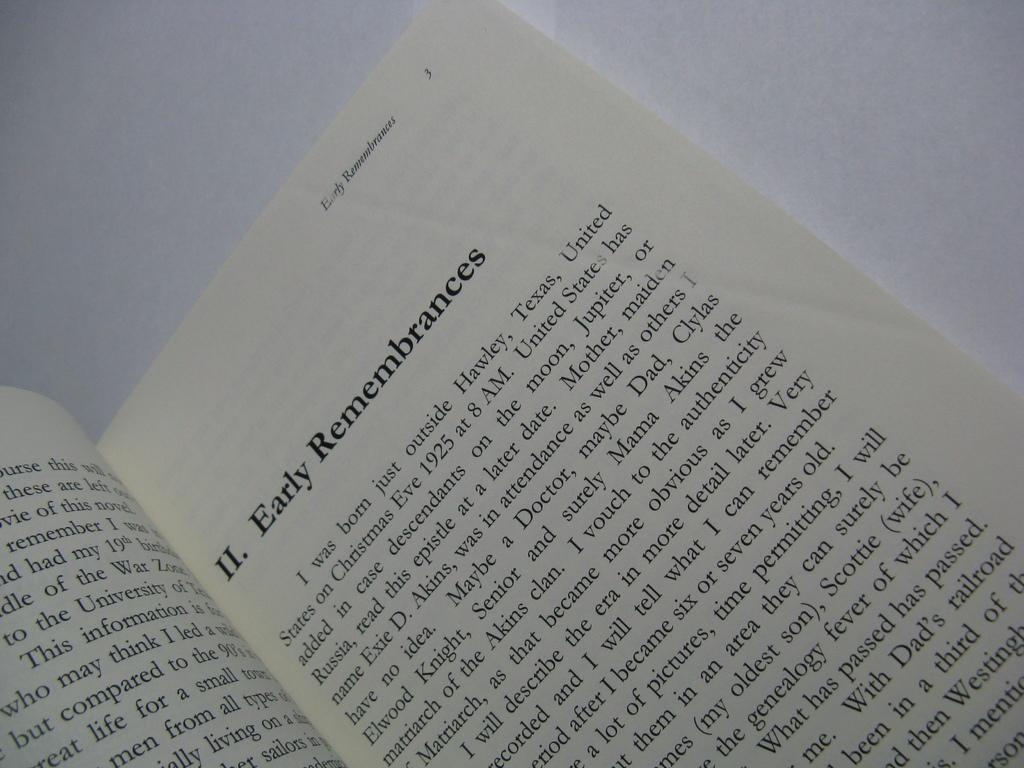<image>
Provide a brief description of the given image. A open book with the heading early remembrances written at top. 